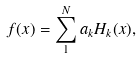<formula> <loc_0><loc_0><loc_500><loc_500>f ( x ) = \sum _ { 1 } ^ { N } a _ { k } H _ { k } ( x ) ,</formula> 